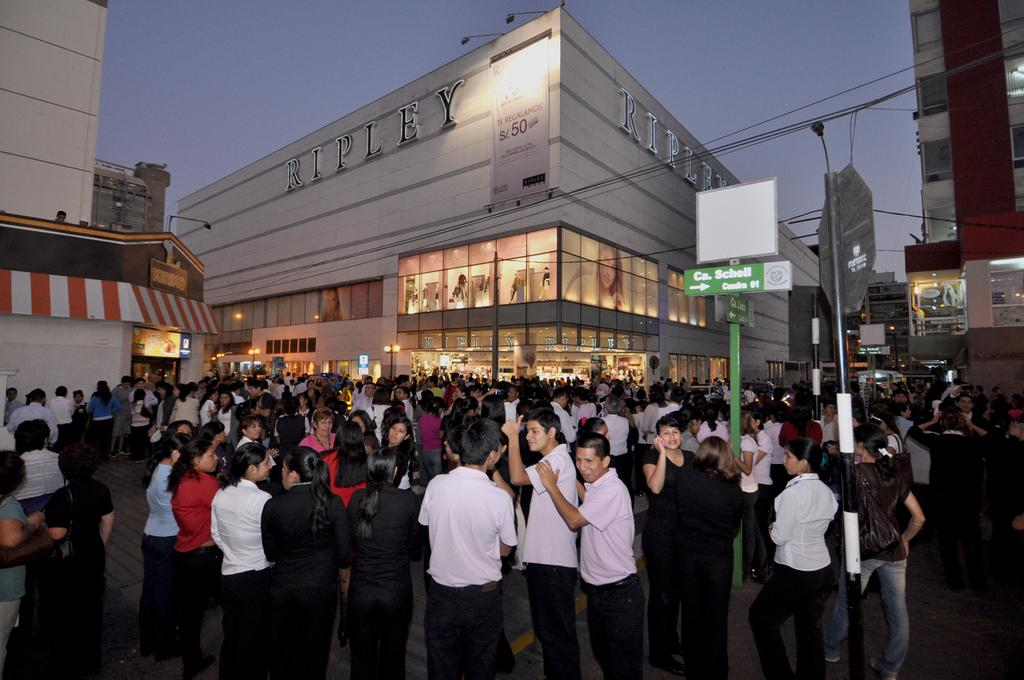What is present in the image? There are people standing in the image. What can be seen in the distance behind the people? There are buildings visible in the background of the image. Can you tell me how many buns are being held by the people in the image? There is no mention of buns in the image, and the people are not holding any. What year is depicted in the image? The image does not depict a specific year; it is a general scene with people and buildings. 